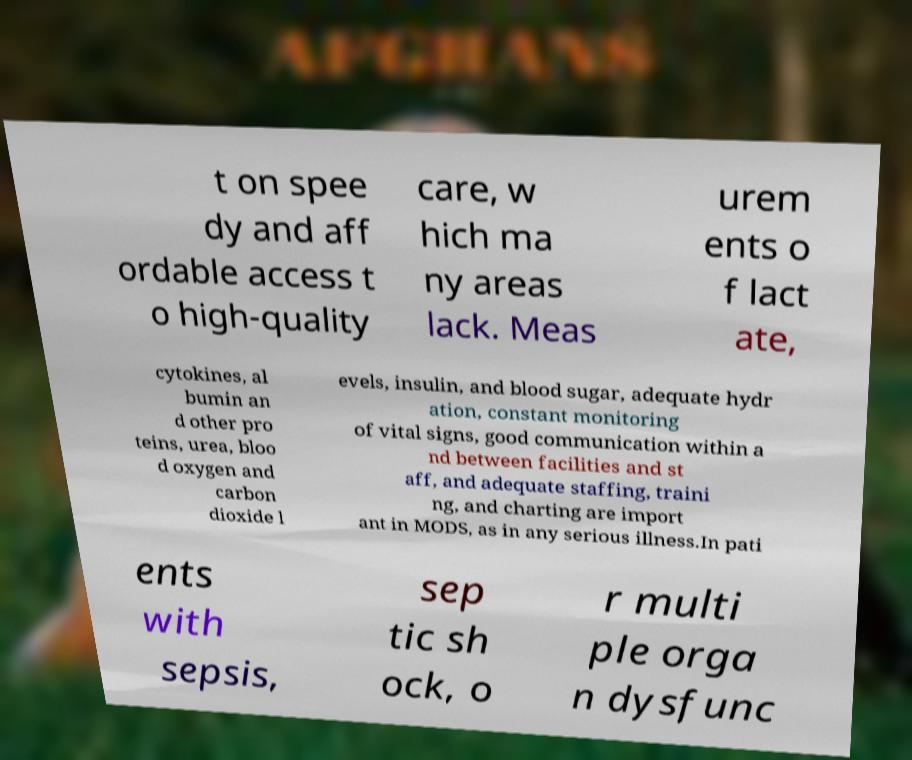There's text embedded in this image that I need extracted. Can you transcribe it verbatim? t on spee dy and aff ordable access t o high-quality care, w hich ma ny areas lack. Meas urem ents o f lact ate, cytokines, al bumin an d other pro teins, urea, bloo d oxygen and carbon dioxide l evels, insulin, and blood sugar, adequate hydr ation, constant monitoring of vital signs, good communication within a nd between facilities and st aff, and adequate staffing, traini ng, and charting are import ant in MODS, as in any serious illness.In pati ents with sepsis, sep tic sh ock, o r multi ple orga n dysfunc 